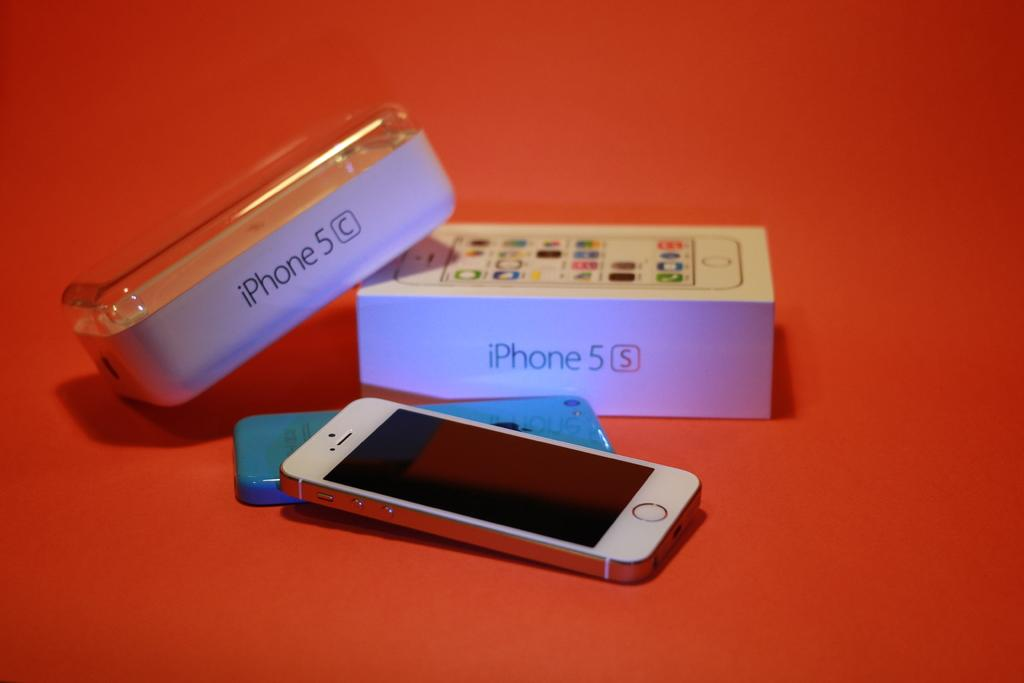<image>
Give a short and clear explanation of the subsequent image. A box from an iPhone 5C sits near a box from a 5S. 